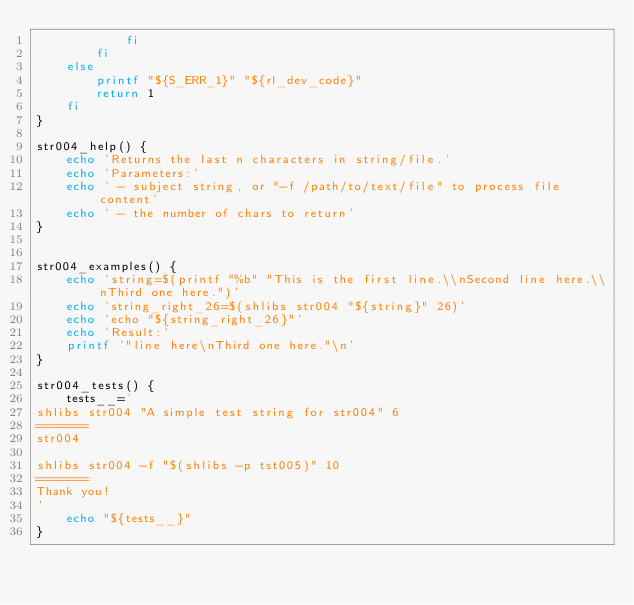<code> <loc_0><loc_0><loc_500><loc_500><_Bash_>			fi
		fi
	else
		printf "${S_ERR_1}" "${rl_dev_code}"
		return 1
	fi
}

str004_help() {
	echo 'Returns the last n characters in string/file.'
	echo 'Parameters:'
	echo ' - subject string, or "-f /path/to/text/file" to process file content'
	echo ' - the number of chars to return'
}


str004_examples() {
	echo 'string=$(printf "%b" "This is the first line.\\nSecond line here.\\nThird one here.")'
	echo 'string_right_26=$(shlibs str004 "${string}" 26)'
	echo 'echo "${string_right_26}"'
	echo 'Result:'
	printf '"line here\nThird one here."\n'
}

str004_tests() {
	tests__='
shlibs str004 "A simple test string for str004" 6
=======
str004

shlibs str004 -f "$(shlibs -p tst005)" 10
=======
Thank you!
'
	echo "${tests__}"
}
</code> 